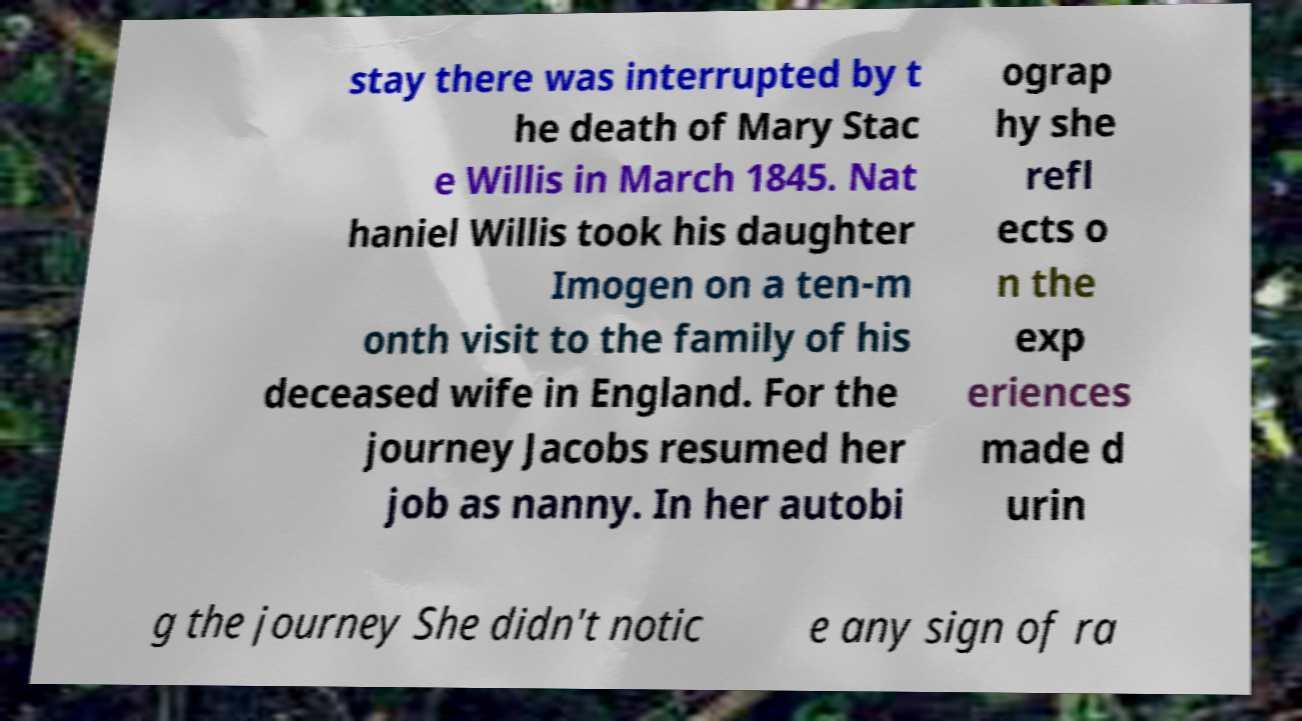Could you assist in decoding the text presented in this image and type it out clearly? stay there was interrupted by t he death of Mary Stac e Willis in March 1845. Nat haniel Willis took his daughter Imogen on a ten-m onth visit to the family of his deceased wife in England. For the journey Jacobs resumed her job as nanny. In her autobi ograp hy she refl ects o n the exp eriences made d urin g the journey She didn't notic e any sign of ra 